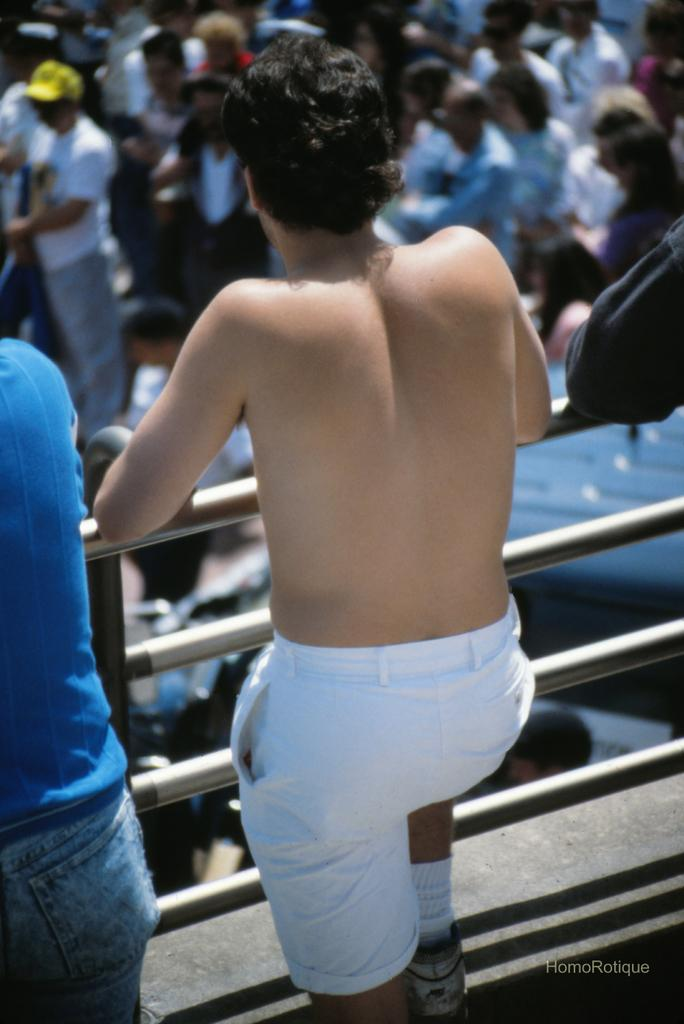Who or what is the main subject of the image? There is a person in the image. What is the person wearing? The person is wearing white shorts. What can be seen near the person in the image? The person is standing near a metal railing. What is visible in the background of the image? There are many people in the background of the image. What angle was used to capture the person's discovery of a new holiday destination? There is no mention of a discovery or a holiday destination in the image, and the angle of the camera is not specified. 